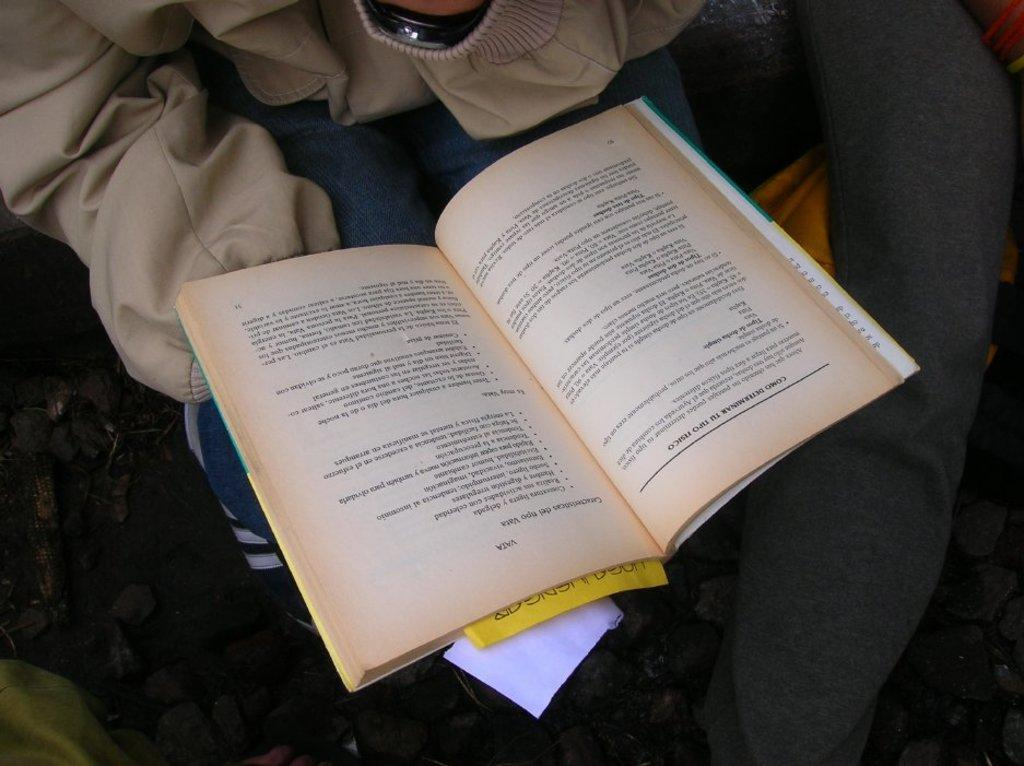What is the main subject of the image? There is a person in the image. What is the person wearing? The person is wearing a jacket. What is the person holding? The person is holding a book. What is inside the book? There are two papers placed in the book. What can be seen in the right corner of the image? There are objects placed in the right corner of the image. How does the person interact with the jellyfish in the image? There are no jellyfish present in the image, so the person cannot interact with them. What is the person pushing in the image? The person is not pushing anything in the image; they are holding a book. 